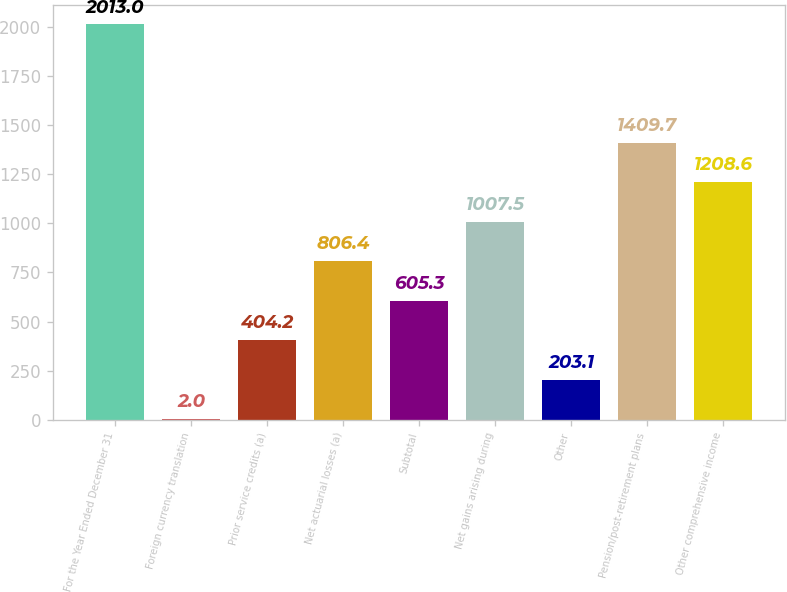Convert chart. <chart><loc_0><loc_0><loc_500><loc_500><bar_chart><fcel>For the Year Ended December 31<fcel>Foreign currency translation<fcel>Prior service credits (a)<fcel>Net actuarial losses (a)<fcel>Subtotal<fcel>Net gains arising during<fcel>Other<fcel>Pension/post-retirement plans<fcel>Other comprehensive income<nl><fcel>2013<fcel>2<fcel>404.2<fcel>806.4<fcel>605.3<fcel>1007.5<fcel>203.1<fcel>1409.7<fcel>1208.6<nl></chart> 